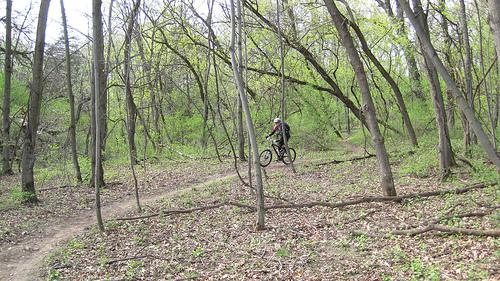Question: what is the person doing?
Choices:
A. Running.
B. Skateboarding.
C. Biking.
D. Jogging.
Answer with the letter. Answer: C Question: who is in the woods?
Choices:
A. The biker.
B. A bear.
C. The woman.
D. A man.
Answer with the letter. Answer: A 